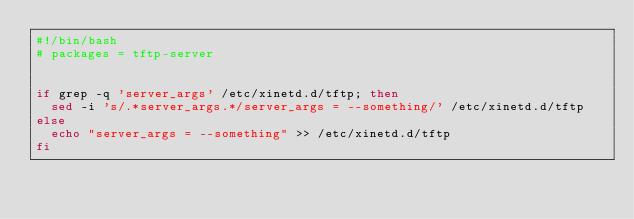<code> <loc_0><loc_0><loc_500><loc_500><_Bash_>#!/bin/bash
# packages = tftp-server


if grep -q 'server_args' /etc/xinetd.d/tftp; then
	sed -i 's/.*server_args.*/server_args = --something/' /etc/xinetd.d/tftp
else
	echo "server_args = --something" >> /etc/xinetd.d/tftp
fi
</code> 